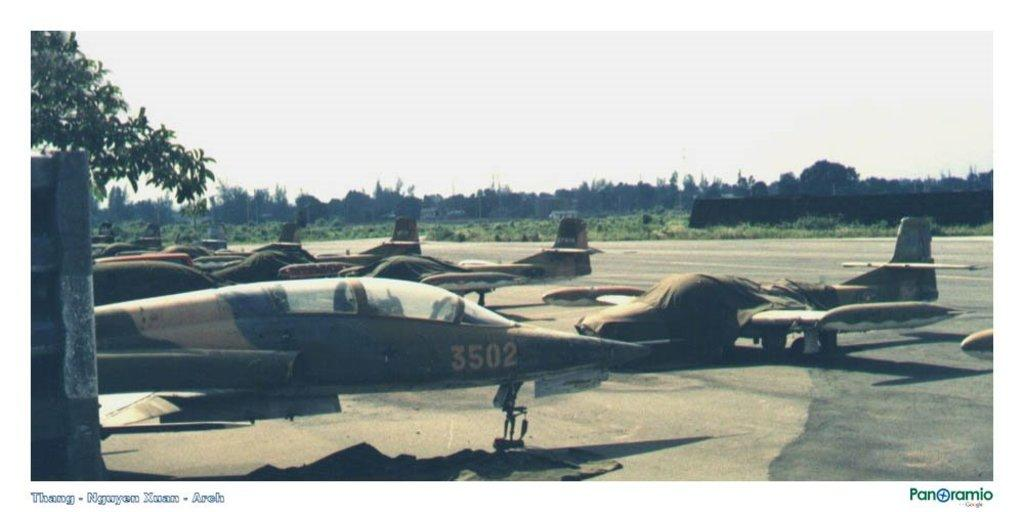What type of vehicles are in the picture? There are jet planes in the picture. What type of natural elements can be seen in the picture? There are trees and plants in the picture. What is the condition of the sky in the picture? The sky is cloudy in the picture. What is present at the bottom left corner of the picture? There is text at the bottom left corner of the picture. What is present at the bottom right corner of the picture? There is text at the bottom right corner of the picture. What type of crime is being committed in the picture? There is no crime being committed in the picture; it features jet planes, trees, plants, and text. What type of insurance policy is being advertised in the picture? There is no insurance policy being advertised in the picture; it only contains text in the bottom corners. 